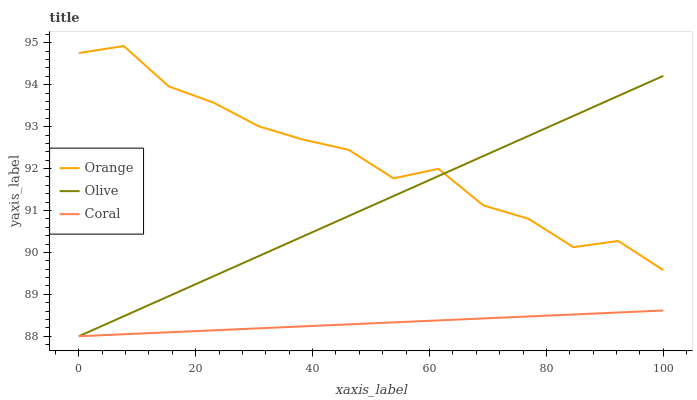Does Coral have the minimum area under the curve?
Answer yes or no. Yes. Does Orange have the maximum area under the curve?
Answer yes or no. Yes. Does Olive have the minimum area under the curve?
Answer yes or no. No. Does Olive have the maximum area under the curve?
Answer yes or no. No. Is Coral the smoothest?
Answer yes or no. Yes. Is Orange the roughest?
Answer yes or no. Yes. Is Olive the smoothest?
Answer yes or no. No. Is Olive the roughest?
Answer yes or no. No. Does Olive have the lowest value?
Answer yes or no. Yes. Does Orange have the highest value?
Answer yes or no. Yes. Does Olive have the highest value?
Answer yes or no. No. Is Coral less than Orange?
Answer yes or no. Yes. Is Orange greater than Coral?
Answer yes or no. Yes. Does Coral intersect Olive?
Answer yes or no. Yes. Is Coral less than Olive?
Answer yes or no. No. Is Coral greater than Olive?
Answer yes or no. No. Does Coral intersect Orange?
Answer yes or no. No. 